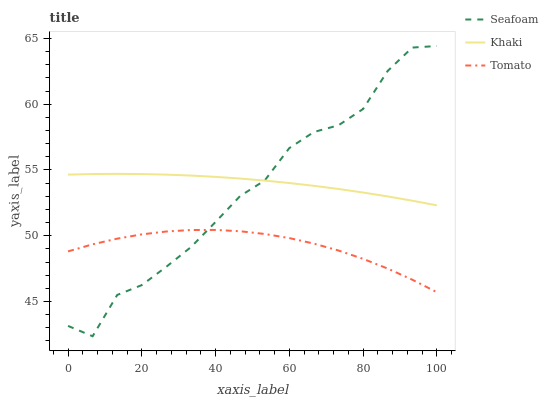Does Tomato have the minimum area under the curve?
Answer yes or no. Yes. Does Khaki have the maximum area under the curve?
Answer yes or no. Yes. Does Seafoam have the minimum area under the curve?
Answer yes or no. No. Does Seafoam have the maximum area under the curve?
Answer yes or no. No. Is Khaki the smoothest?
Answer yes or no. Yes. Is Seafoam the roughest?
Answer yes or no. Yes. Is Seafoam the smoothest?
Answer yes or no. No. Is Khaki the roughest?
Answer yes or no. No. Does Khaki have the lowest value?
Answer yes or no. No. Does Khaki have the highest value?
Answer yes or no. No. Is Tomato less than Khaki?
Answer yes or no. Yes. Is Khaki greater than Tomato?
Answer yes or no. Yes. Does Tomato intersect Khaki?
Answer yes or no. No. 